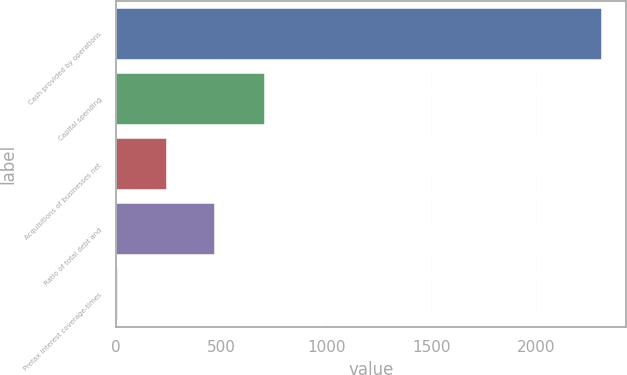Convert chart to OTSL. <chart><loc_0><loc_0><loc_500><loc_500><bar_chart><fcel>Cash provided by operations<fcel>Capital spending<fcel>Acquisitions of businesses net<fcel>Ratio of total debt and<fcel>Pretax interest coverage-times<nl><fcel>2311.8<fcel>709.6<fcel>239.55<fcel>469.8<fcel>9.3<nl></chart> 